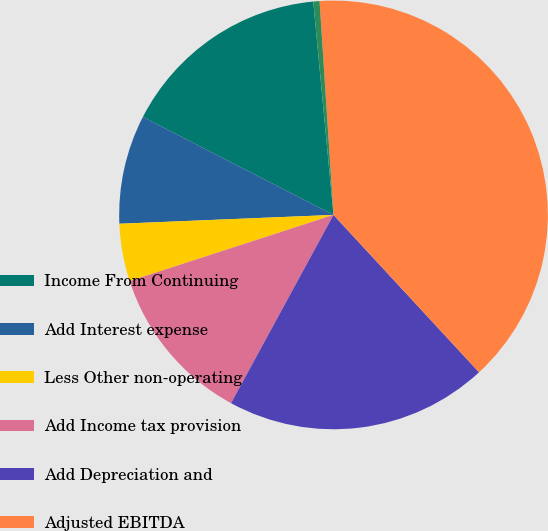Convert chart to OTSL. <chart><loc_0><loc_0><loc_500><loc_500><pie_chart><fcel>Income From Continuing<fcel>Add Interest expense<fcel>Less Other non-operating<fcel>Add Income tax provision<fcel>Add Depreciation and<fcel>Adjusted EBITDA<fcel>Adjusted EBITDA margin<nl><fcel>15.94%<fcel>8.21%<fcel>4.34%<fcel>12.07%<fcel>19.81%<fcel>39.16%<fcel>0.47%<nl></chart> 